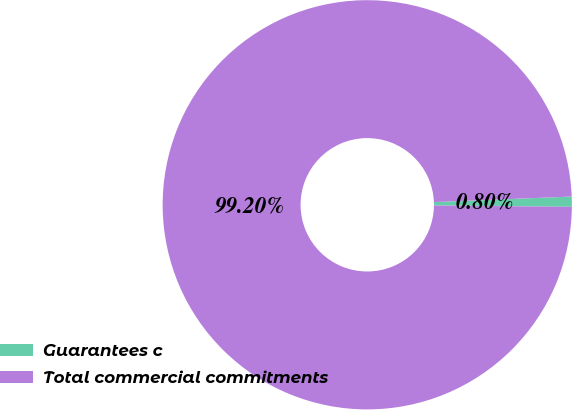Convert chart to OTSL. <chart><loc_0><loc_0><loc_500><loc_500><pie_chart><fcel>Guarantees c<fcel>Total commercial commitments<nl><fcel>0.8%<fcel>99.2%<nl></chart> 